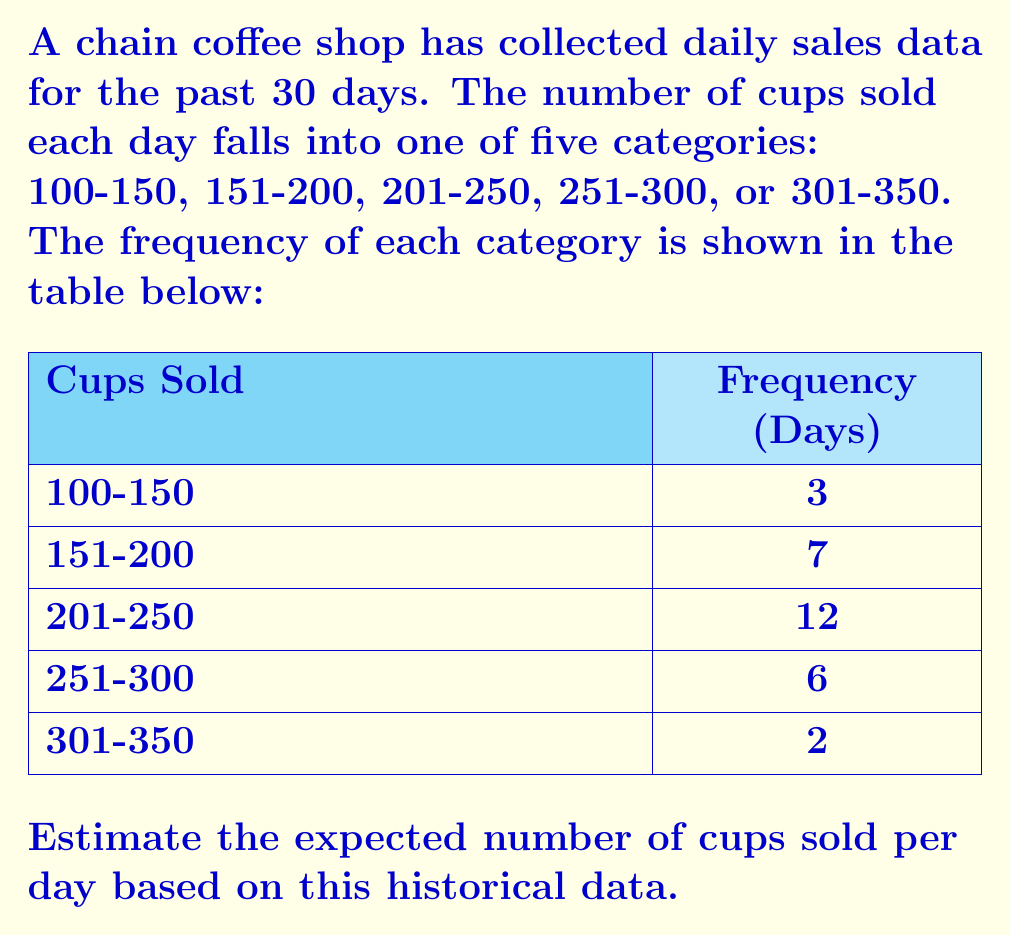Can you solve this math problem? To calculate the expected number of cups sold per day, we need to follow these steps:

1. Find the midpoint of each range to represent the average number of cups sold for that category.
2. Calculate the probability of each category occurring.
3. Multiply the midpoint by the probability for each category.
4. Sum up all the products to get the expected value.

Step 1: Midpoints
- 100-150: $\frac{100 + 150}{2} = 125$
- 151-200: $\frac{151 + 200}{2} = 175.5$
- 201-250: $\frac{201 + 250}{2} = 225.5$
- 251-300: $\frac{251 + 300}{2} = 275.5$
- 301-350: $\frac{301 + 350}{2} = 325.5$

Step 2: Probabilities
Total days = 30
- 100-150: $P(100-150) = \frac{3}{30} = 0.1$
- 151-200: $P(151-200) = \frac{7}{30} \approx 0.2333$
- 201-250: $P(201-250) = \frac{12}{30} = 0.4$
- 251-300: $P(251-300) = \frac{6}{30} = 0.2$
- 301-350: $P(301-350) = \frac{2}{30} \approx 0.0667$

Step 3 & 4: Calculate expected value
$$E = 125 \cdot 0.1 + 175.5 \cdot 0.2333 + 225.5 \cdot 0.4 + 275.5 \cdot 0.2 + 325.5 \cdot 0.0667$$
$$E = 12.5 + 40.94 + 90.2 + 55.1 + 21.71$$
$$E = 220.45$$

Therefore, the expected number of cups sold per day is approximately 220.45 cups.
Answer: 220.45 cups 